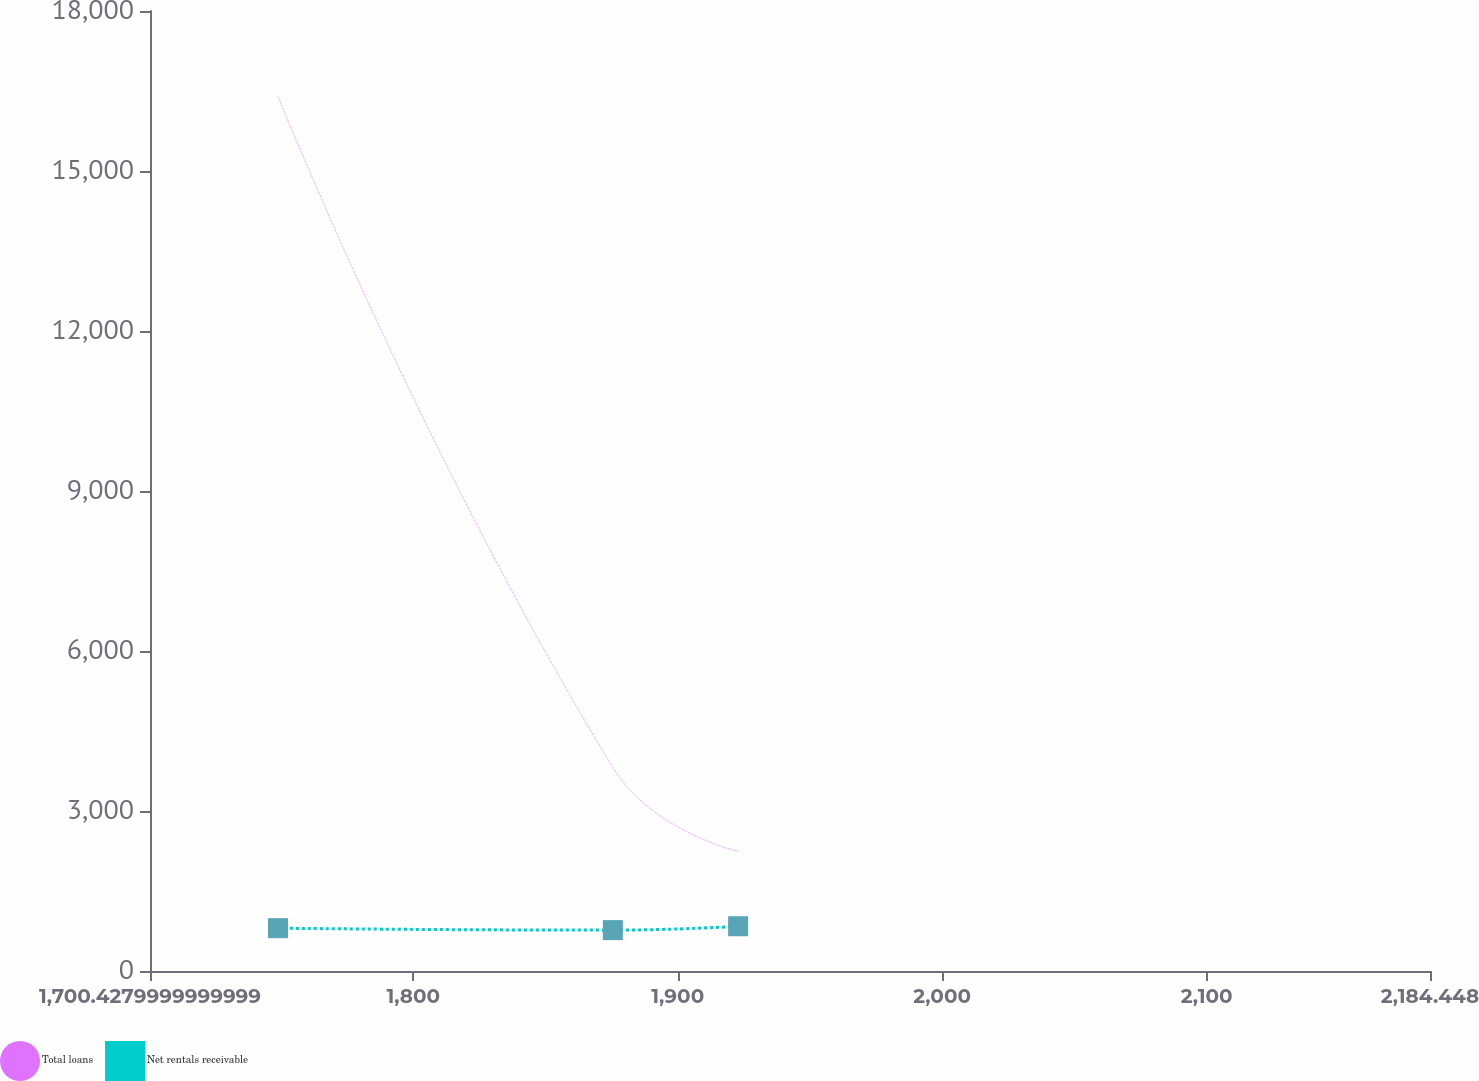Convert chart. <chart><loc_0><loc_0><loc_500><loc_500><line_chart><ecel><fcel>Total loans<fcel>Net rentals receivable<nl><fcel>1748.83<fcel>16398.8<fcel>802.8<nl><fcel>1875.45<fcel>3812.2<fcel>766.35<nl><fcel>1922.82<fcel>2238.88<fcel>839.25<nl><fcel>2185.48<fcel>5385.52<fcel>553.61<nl><fcel>2232.85<fcel>665.56<fcel>415.57<nl></chart> 